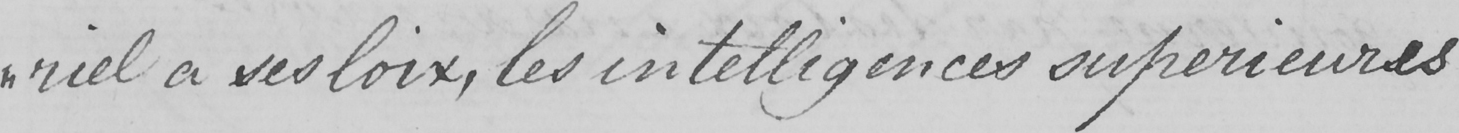What text is written in this handwritten line? " riel a ses loix , les intelligences superieures 